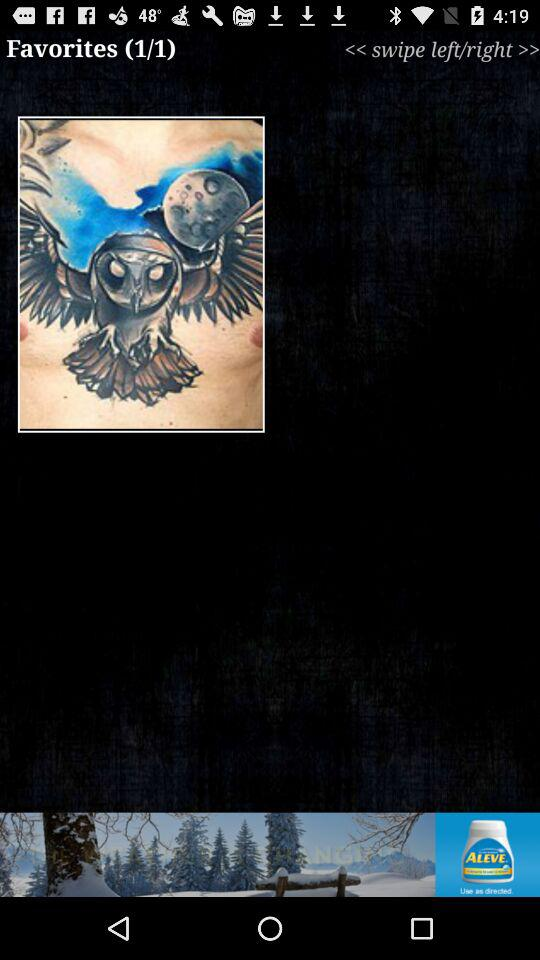What is the number of items in "Favorites"? The number of items is 1. 